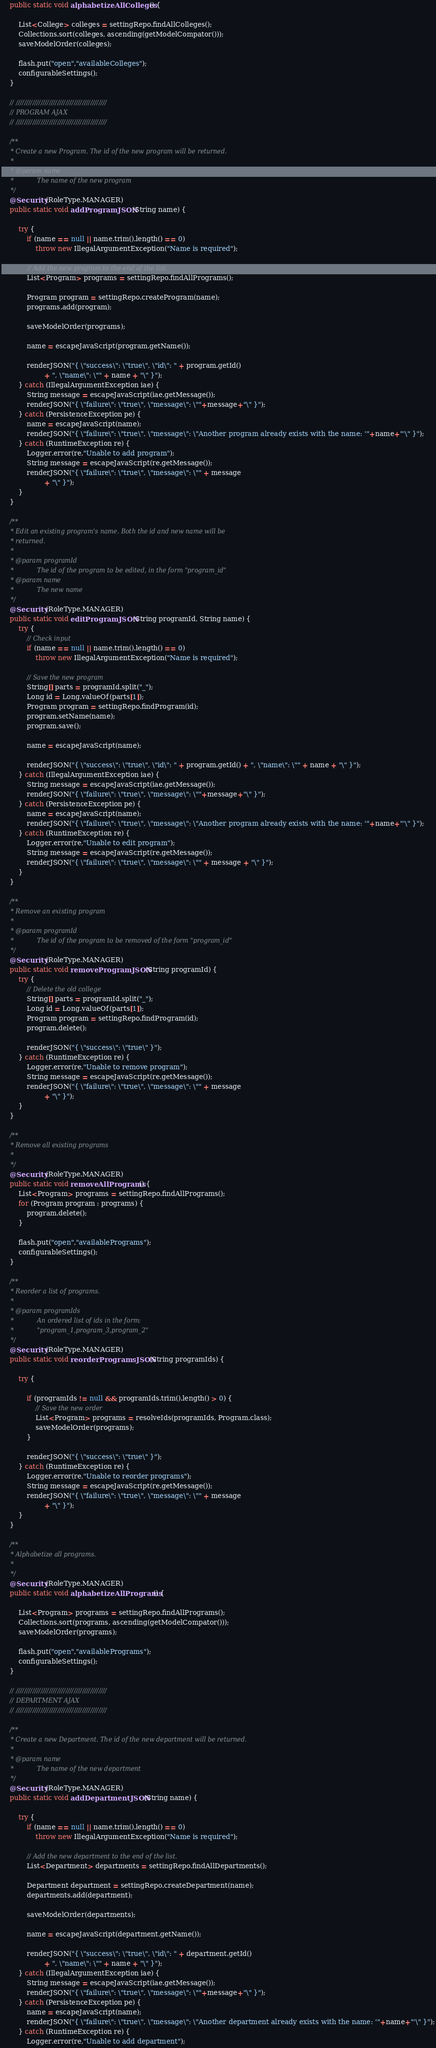<code> <loc_0><loc_0><loc_500><loc_500><_Java_>	public static void alphabetizeAllColleges() {

		List<College> colleges = settingRepo.findAllColleges();
		Collections.sort(colleges, ascending(getModelCompator()));
		saveModelOrder(colleges);
		
		flash.put("open","availableColleges");
		configurableSettings();
	}
	
	// ////////////////////////////////////////////
	// PROGRAM AJAX
	// ////////////////////////////////////////////

	/**
	 * Create a new Program. The id of the new program will be returned.
	 * 
	 * @param name
	 *            The name of the new program
	 */
	@Security(RoleType.MANAGER)
	public static void addProgramJSON(String name) {

		try {
			if (name == null || name.trim().length() == 0)
				throw new IllegalArgumentException("Name is required");

			// Add the new program to the end of the list.
			List<Program> programs = settingRepo.findAllPrograms();

			Program program = settingRepo.createProgram(name);
			programs.add(program);

			saveModelOrder(programs);

			name = escapeJavaScript(program.getName());

			renderJSON("{ \"success\": \"true\", \"id\": " + program.getId()
					+ ", \"name\": \"" + name + "\" }");
		} catch (IllegalArgumentException iae) {
			String message = escapeJavaScript(iae.getMessage());			
			renderJSON("{ \"failure\": \"true\", \"message\": \""+message+"\" }");
		} catch (PersistenceException pe) {
			name = escapeJavaScript(name);
			renderJSON("{ \"failure\": \"true\", \"message\": \"Another program already exists with the name: '"+name+"'\" }");
		} catch (RuntimeException re) {
			Logger.error(re,"Unable to add program");
			String message = escapeJavaScript(re.getMessage());
			renderJSON("{ \"failure\": \"true\", \"message\": \"" + message
					+ "\" }");
		}
	}

	/**
	 * Edit an existing program's name. Both the id and new name will be
	 * returned.
	 * 
	 * @param programId
	 *            The id of the program to be edited, in the form "program_id"
	 * @param name
	 *            The new name
	 */
	@Security(RoleType.MANAGER)
	public static void editProgramJSON(String programId, String name) {
		try {
			// Check input
			if (name == null || name.trim().length() == 0)
				throw new IllegalArgumentException("Name is required");

			// Save the new program
			String[] parts = programId.split("_");
			Long id = Long.valueOf(parts[1]);
			Program program = settingRepo.findProgram(id);
			program.setName(name);
			program.save();

			name = escapeJavaScript(name);

			renderJSON("{ \"success\": \"true\", \"id\": " + program.getId() + ", \"name\": \"" + name + "\" }");
		} catch (IllegalArgumentException iae) {
			String message = escapeJavaScript(iae.getMessage());			
			renderJSON("{ \"failure\": \"true\", \"message\": \""+message+"\" }");
		} catch (PersistenceException pe) {
			name = escapeJavaScript(name);
			renderJSON("{ \"failure\": \"true\", \"message\": \"Another program already exists with the name: '"+name+"'\" }");
		} catch (RuntimeException re) {
			Logger.error(re,"Unable to edit program");
			String message = escapeJavaScript(re.getMessage());
			renderJSON("{ \"failure\": \"true\", \"message\": \"" + message + "\" }");
		}
	}

	/**
	 * Remove an existing program
	 * 
	 * @param programId
	 *            The id of the program to be removed of the form "program_id"
	 */
	@Security(RoleType.MANAGER)
	public static void removeProgramJSON(String programId) {
		try {
			// Delete the old college
			String[] parts = programId.split("_");
			Long id = Long.valueOf(parts[1]);
			Program program = settingRepo.findProgram(id);
			program.delete();

			renderJSON("{ \"success\": \"true\" }");
		} catch (RuntimeException re) {
			Logger.error(re,"Unable to remove program");
			String message = escapeJavaScript(re.getMessage());
			renderJSON("{ \"failure\": \"true\", \"message\": \"" + message
					+ "\" }");
		}
	}
	
	/**
	 * Remove all existing programs
	 * 
	 */
	@Security(RoleType.MANAGER)
	public static void removeAllPrograms() {
		List<Program> programs = settingRepo.findAllPrograms();
		for (Program program : programs) {
			program.delete();
		}

		flash.put("open","availablePrograms");
		configurableSettings();
	}

	/**
	 * Reorder a list of programs.
	 * 
	 * @param programIds
	 *            An ordered list of ids in the form:
	 *            "program_1,program_3,program_2"
	 */
	@Security(RoleType.MANAGER)
	public static void reorderProgramsJSON(String programIds) {

		try {

			if (programIds != null && programIds.trim().length() > 0) {
				// Save the new order
				List<Program> programs = resolveIds(programIds, Program.class);
				saveModelOrder(programs);
			}

			renderJSON("{ \"success\": \"true\" }");
		} catch (RuntimeException re) {
			Logger.error(re,"Unable to reorder programs");
			String message = escapeJavaScript(re.getMessage());
			renderJSON("{ \"failure\": \"true\", \"message\": \"" + message
					+ "\" }");
		}
	}
	
	/**
	 * Alphabetize all programs.
	 * 
	 */
	@Security(RoleType.MANAGER)
	public static void alphabetizeAllPrograms() {

		List<Program> programs = settingRepo.findAllPrograms();
		Collections.sort(programs, ascending(getModelCompator()));
		saveModelOrder(programs);
		
		flash.put("open","availablePrograms");
		configurableSettings();
	}

	// ////////////////////////////////////////////
	// DEPARTMENT AJAX
	// ////////////////////////////////////////////

	/**
	 * Create a new Department. The id of the new department will be returned.
	 * 
	 * @param name
	 *            The name of the new department
	 */
	@Security(RoleType.MANAGER)
	public static void addDepartmentJSON(String name) {

		try {
			if (name == null || name.trim().length() == 0)
				throw new IllegalArgumentException("Name is required");

			// Add the new department to the end of the list.
			List<Department> departments = settingRepo.findAllDepartments();

			Department department = settingRepo.createDepartment(name);
			departments.add(department);

			saveModelOrder(departments);

			name = escapeJavaScript(department.getName());

			renderJSON("{ \"success\": \"true\", \"id\": " + department.getId()
					+ ", \"name\": \"" + name + "\" }");
		} catch (IllegalArgumentException iae) {
			String message = escapeJavaScript(iae.getMessage());			
			renderJSON("{ \"failure\": \"true\", \"message\": \""+message+"\" }");
		} catch (PersistenceException pe) {
			name = escapeJavaScript(name);
			renderJSON("{ \"failure\": \"true\", \"message\": \"Another department already exists with the name: '"+name+"'\" }");
		} catch (RuntimeException re) {
			Logger.error(re,"Unable to add department");</code> 